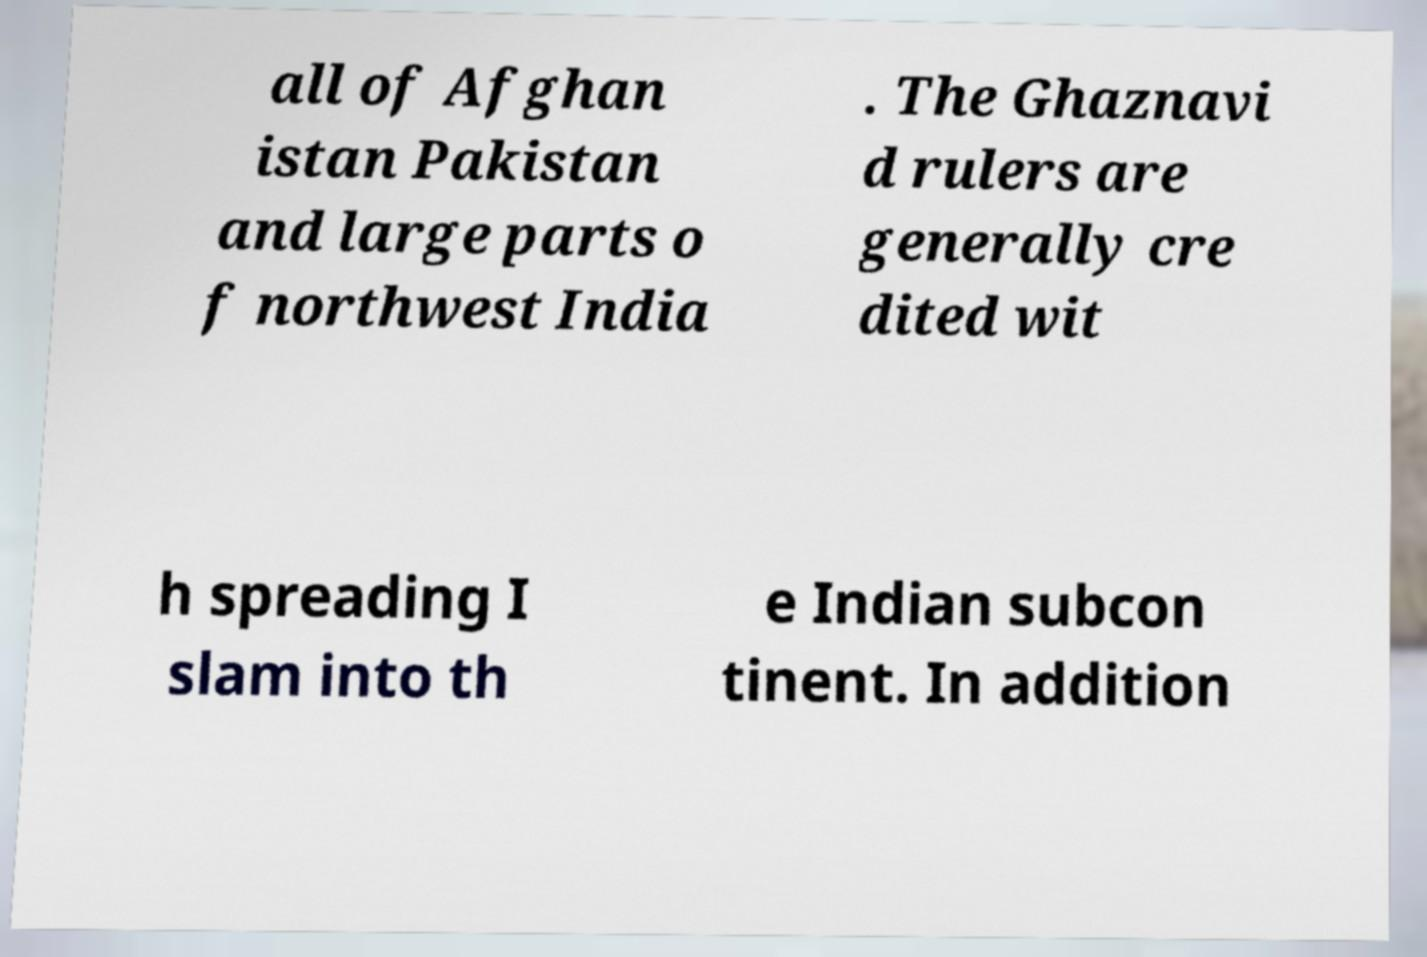I need the written content from this picture converted into text. Can you do that? all of Afghan istan Pakistan and large parts o f northwest India . The Ghaznavi d rulers are generally cre dited wit h spreading I slam into th e Indian subcon tinent. In addition 